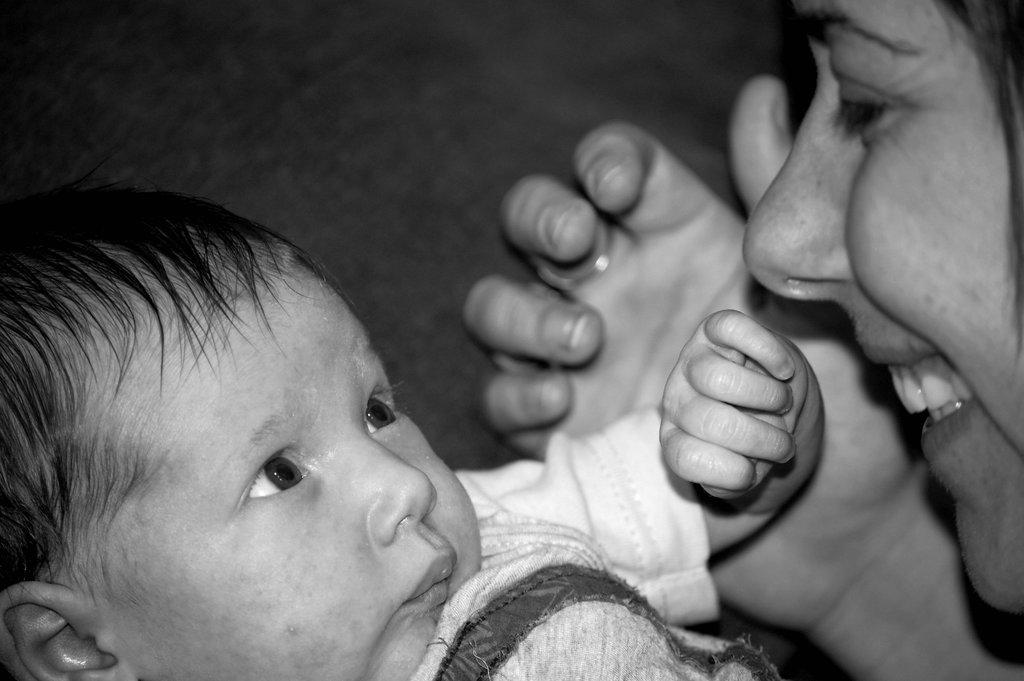What is the main subject of the image? There is a baby in the image. Who is present with the baby in the image? There is a woman in the image. What is the woman's expression in the image? The woman is smiling. What is the color scheme of the image? The image is black and white. What type of government is depicted in the image? There is no depiction of a government in the image; it features a baby and a smiling woman. How many cows can be seen in the image? There are no cows present in the image. 